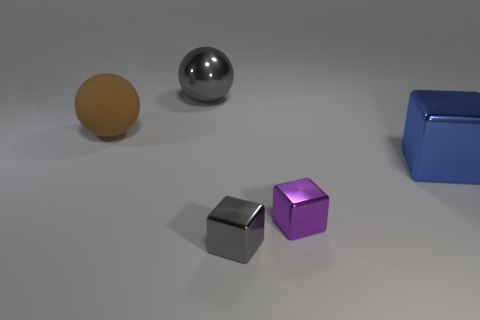Subtract all brown metal things. Subtract all gray cubes. How many objects are left? 4 Add 5 small purple cubes. How many small purple cubes are left? 6 Add 1 brown matte spheres. How many brown matte spheres exist? 2 Add 2 blue shiny things. How many objects exist? 7 Subtract all purple blocks. How many blocks are left? 2 Subtract all small gray metal blocks. How many blocks are left? 2 Subtract 0 yellow cubes. How many objects are left? 5 Subtract all balls. How many objects are left? 3 Subtract 1 balls. How many balls are left? 1 Subtract all gray balls. Subtract all cyan cylinders. How many balls are left? 1 